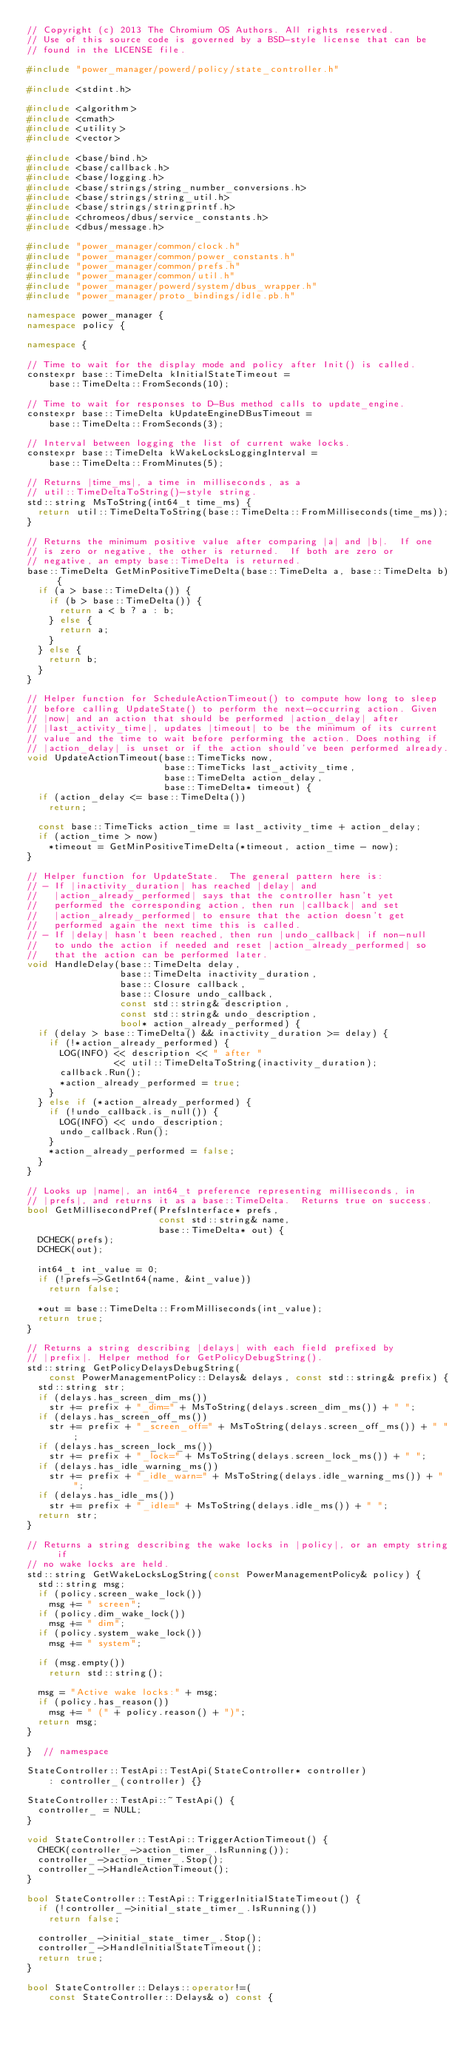<code> <loc_0><loc_0><loc_500><loc_500><_C++_>// Copyright (c) 2013 The Chromium OS Authors. All rights reserved.
// Use of this source code is governed by a BSD-style license that can be
// found in the LICENSE file.

#include "power_manager/powerd/policy/state_controller.h"

#include <stdint.h>

#include <algorithm>
#include <cmath>
#include <utility>
#include <vector>

#include <base/bind.h>
#include <base/callback.h>
#include <base/logging.h>
#include <base/strings/string_number_conversions.h>
#include <base/strings/string_util.h>
#include <base/strings/stringprintf.h>
#include <chromeos/dbus/service_constants.h>
#include <dbus/message.h>

#include "power_manager/common/clock.h"
#include "power_manager/common/power_constants.h"
#include "power_manager/common/prefs.h"
#include "power_manager/common/util.h"
#include "power_manager/powerd/system/dbus_wrapper.h"
#include "power_manager/proto_bindings/idle.pb.h"

namespace power_manager {
namespace policy {

namespace {

// Time to wait for the display mode and policy after Init() is called.
constexpr base::TimeDelta kInitialStateTimeout =
    base::TimeDelta::FromSeconds(10);

// Time to wait for responses to D-Bus method calls to update_engine.
constexpr base::TimeDelta kUpdateEngineDBusTimeout =
    base::TimeDelta::FromSeconds(3);

// Interval between logging the list of current wake locks.
constexpr base::TimeDelta kWakeLocksLoggingInterval =
    base::TimeDelta::FromMinutes(5);

// Returns |time_ms|, a time in milliseconds, as a
// util::TimeDeltaToString()-style string.
std::string MsToString(int64_t time_ms) {
  return util::TimeDeltaToString(base::TimeDelta::FromMilliseconds(time_ms));
}

// Returns the minimum positive value after comparing |a| and |b|.  If one
// is zero or negative, the other is returned.  If both are zero or
// negative, an empty base::TimeDelta is returned.
base::TimeDelta GetMinPositiveTimeDelta(base::TimeDelta a, base::TimeDelta b) {
  if (a > base::TimeDelta()) {
    if (b > base::TimeDelta()) {
      return a < b ? a : b;
    } else {
      return a;
    }
  } else {
    return b;
  }
}

// Helper function for ScheduleActionTimeout() to compute how long to sleep
// before calling UpdateState() to perform the next-occurring action. Given
// |now| and an action that should be performed |action_delay| after
// |last_activity_time|, updates |timeout| to be the minimum of its current
// value and the time to wait before performing the action. Does nothing if
// |action_delay| is unset or if the action should've been performed already.
void UpdateActionTimeout(base::TimeTicks now,
                         base::TimeTicks last_activity_time,
                         base::TimeDelta action_delay,
                         base::TimeDelta* timeout) {
  if (action_delay <= base::TimeDelta())
    return;

  const base::TimeTicks action_time = last_activity_time + action_delay;
  if (action_time > now)
    *timeout = GetMinPositiveTimeDelta(*timeout, action_time - now);
}

// Helper function for UpdateState.  The general pattern here is:
// - If |inactivity_duration| has reached |delay| and
//   |action_already_performed| says that the controller hasn't yet
//   performed the corresponding action, then run |callback| and set
//   |action_already_performed| to ensure that the action doesn't get
//   performed again the next time this is called.
// - If |delay| hasn't been reached, then run |undo_callback| if non-null
//   to undo the action if needed and reset |action_already_performed| so
//   that the action can be performed later.
void HandleDelay(base::TimeDelta delay,
                 base::TimeDelta inactivity_duration,
                 base::Closure callback,
                 base::Closure undo_callback,
                 const std::string& description,
                 const std::string& undo_description,
                 bool* action_already_performed) {
  if (delay > base::TimeDelta() && inactivity_duration >= delay) {
    if (!*action_already_performed) {
      LOG(INFO) << description << " after "
                << util::TimeDeltaToString(inactivity_duration);
      callback.Run();
      *action_already_performed = true;
    }
  } else if (*action_already_performed) {
    if (!undo_callback.is_null()) {
      LOG(INFO) << undo_description;
      undo_callback.Run();
    }
    *action_already_performed = false;
  }
}

// Looks up |name|, an int64_t preference representing milliseconds, in
// |prefs|, and returns it as a base::TimeDelta.  Returns true on success.
bool GetMillisecondPref(PrefsInterface* prefs,
                        const std::string& name,
                        base::TimeDelta* out) {
  DCHECK(prefs);
  DCHECK(out);

  int64_t int_value = 0;
  if (!prefs->GetInt64(name, &int_value))
    return false;

  *out = base::TimeDelta::FromMilliseconds(int_value);
  return true;
}

// Returns a string describing |delays| with each field prefixed by
// |prefix|. Helper method for GetPolicyDebugString().
std::string GetPolicyDelaysDebugString(
    const PowerManagementPolicy::Delays& delays, const std::string& prefix) {
  std::string str;
  if (delays.has_screen_dim_ms())
    str += prefix + "_dim=" + MsToString(delays.screen_dim_ms()) + " ";
  if (delays.has_screen_off_ms())
    str += prefix + "_screen_off=" + MsToString(delays.screen_off_ms()) + " ";
  if (delays.has_screen_lock_ms())
    str += prefix + "_lock=" + MsToString(delays.screen_lock_ms()) + " ";
  if (delays.has_idle_warning_ms())
    str += prefix + "_idle_warn=" + MsToString(delays.idle_warning_ms()) + " ";
  if (delays.has_idle_ms())
    str += prefix + "_idle=" + MsToString(delays.idle_ms()) + " ";
  return str;
}

// Returns a string describing the wake locks in |policy|, or an empty string if
// no wake locks are held.
std::string GetWakeLocksLogString(const PowerManagementPolicy& policy) {
  std::string msg;
  if (policy.screen_wake_lock())
    msg += " screen";
  if (policy.dim_wake_lock())
    msg += " dim";
  if (policy.system_wake_lock())
    msg += " system";

  if (msg.empty())
    return std::string();

  msg = "Active wake locks:" + msg;
  if (policy.has_reason())
    msg += " (" + policy.reason() + ")";
  return msg;
}

}  // namespace

StateController::TestApi::TestApi(StateController* controller)
    : controller_(controller) {}

StateController::TestApi::~TestApi() {
  controller_ = NULL;
}

void StateController::TestApi::TriggerActionTimeout() {
  CHECK(controller_->action_timer_.IsRunning());
  controller_->action_timer_.Stop();
  controller_->HandleActionTimeout();
}

bool StateController::TestApi::TriggerInitialStateTimeout() {
  if (!controller_->initial_state_timer_.IsRunning())
    return false;

  controller_->initial_state_timer_.Stop();
  controller_->HandleInitialStateTimeout();
  return true;
}

bool StateController::Delays::operator!=(
    const StateController::Delays& o) const {</code> 